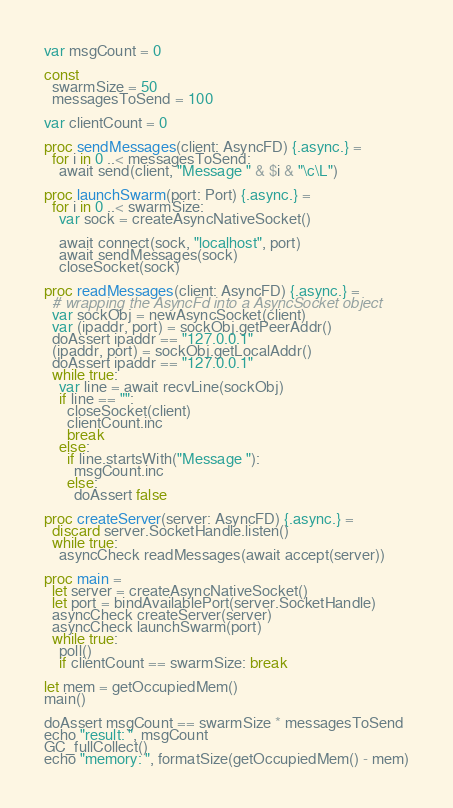Convert code to text. <code><loc_0><loc_0><loc_500><loc_500><_Nim_>
var msgCount = 0

const
  swarmSize = 50
  messagesToSend = 100

var clientCount = 0

proc sendMessages(client: AsyncFD) {.async.} =
  for i in 0 ..< messagesToSend:
    await send(client, "Message " & $i & "\c\L")

proc launchSwarm(port: Port) {.async.} =
  for i in 0 ..< swarmSize:
    var sock = createAsyncNativeSocket()

    await connect(sock, "localhost", port)
    await sendMessages(sock)
    closeSocket(sock)

proc readMessages(client: AsyncFD) {.async.} =
  # wrapping the AsyncFd into a AsyncSocket object
  var sockObj = newAsyncSocket(client)
  var (ipaddr, port) = sockObj.getPeerAddr()
  doAssert ipaddr == "127.0.0.1"
  (ipaddr, port) = sockObj.getLocalAddr()
  doAssert ipaddr == "127.0.0.1"
  while true:
    var line = await recvLine(sockObj)
    if line == "":
      closeSocket(client)
      clientCount.inc
      break
    else:
      if line.startsWith("Message "):
        msgCount.inc
      else:
        doAssert false

proc createServer(server: AsyncFD) {.async.} =
  discard server.SocketHandle.listen()
  while true:
    asyncCheck readMessages(await accept(server))

proc main =
  let server = createAsyncNativeSocket()
  let port = bindAvailablePort(server.SocketHandle)
  asyncCheck createServer(server)
  asyncCheck launchSwarm(port)
  while true:
    poll()
    if clientCount == swarmSize: break

let mem = getOccupiedMem()
main()

doAssert msgCount == swarmSize * messagesToSend
echo "result: ", msgCount
GC_fullCollect()
echo "memory: ", formatSize(getOccupiedMem() - mem)
</code> 